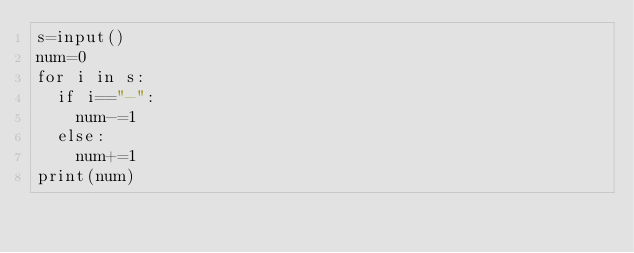<code> <loc_0><loc_0><loc_500><loc_500><_Python_>s=input()
num=0
for i in s:
  if i=="-":
    num-=1
  else:
    num+=1
print(num)</code> 